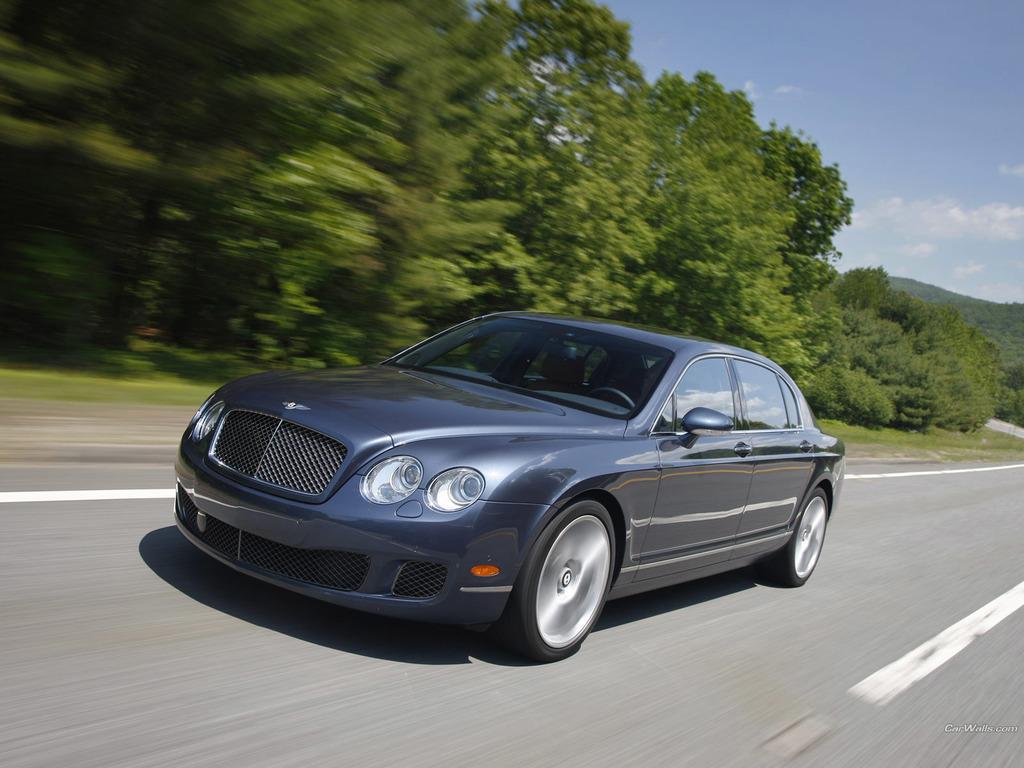Describe this image in one or two sentences. In this picture we can see a car on the road. There are few trees on the left side. Sky is cloudy. 